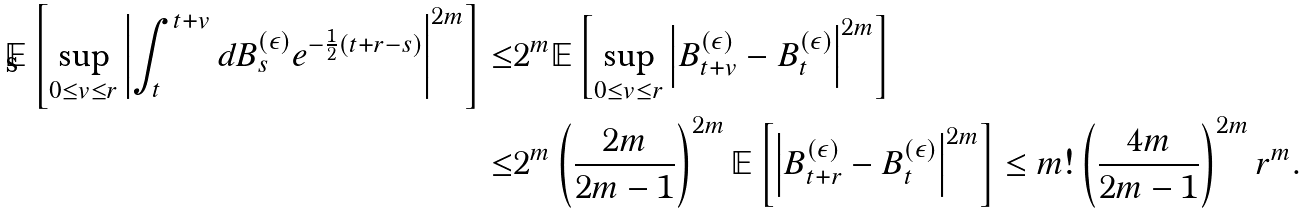Convert formula to latex. <formula><loc_0><loc_0><loc_500><loc_500>\mathbb { E } \left [ \sup _ { 0 \leq v \leq r } \left | \int _ { t } ^ { t + v } d B _ { s } ^ { ( \epsilon ) } e ^ { - \frac { 1 } { 2 } ( t + r - s ) } \right | ^ { 2 m } \right ] \leq & 2 ^ { m } \mathbb { E } \left [ \sup _ { 0 \leq v \leq r } \left | B _ { t + v } ^ { ( \epsilon ) } - B _ { t } ^ { ( \epsilon ) } \right | ^ { 2 m } \right ] \\ \leq & 2 ^ { m } \left ( \frac { 2 m } { 2 m - 1 } \right ) ^ { 2 m } \mathbb { E } \left [ \left | B _ { t + r } ^ { ( \epsilon ) } - B _ { t } ^ { ( \epsilon ) } \right | ^ { 2 m } \right ] \leq m ! \left ( \frac { 4 m } { 2 m - 1 } \right ) ^ { 2 m } r ^ { m } .</formula> 